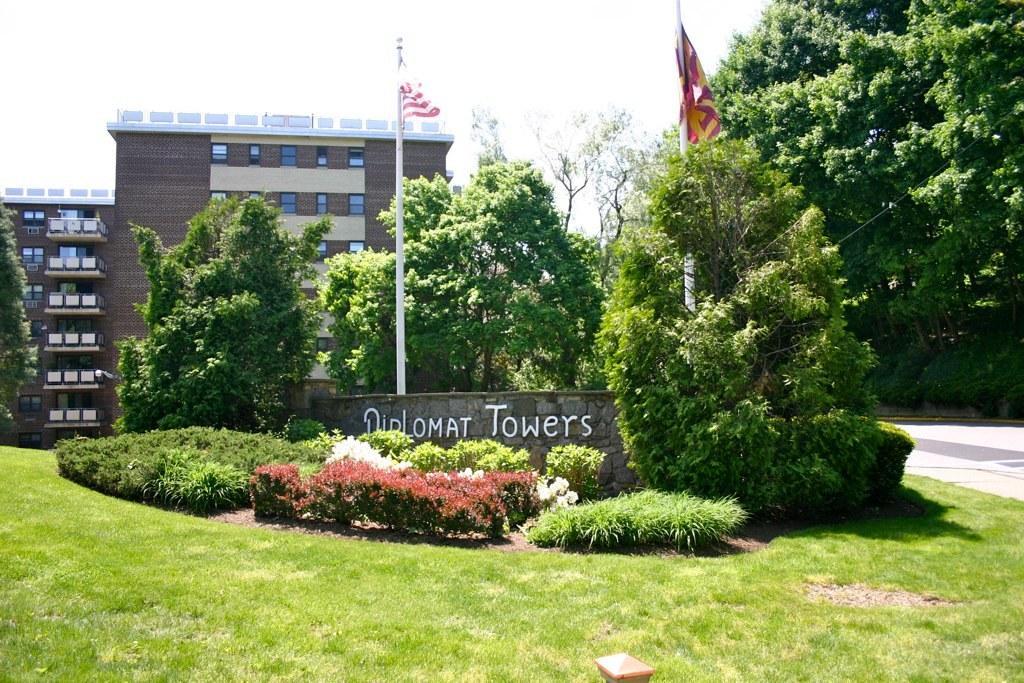Could you give a brief overview of what you see in this image? These are the buildings with windows and glass doors. I can see two flags hanging to the poles. This looks like a name board, which is attached to the wall. These are the trees and small bushes. Here is the grass. This looks like a pathway. 